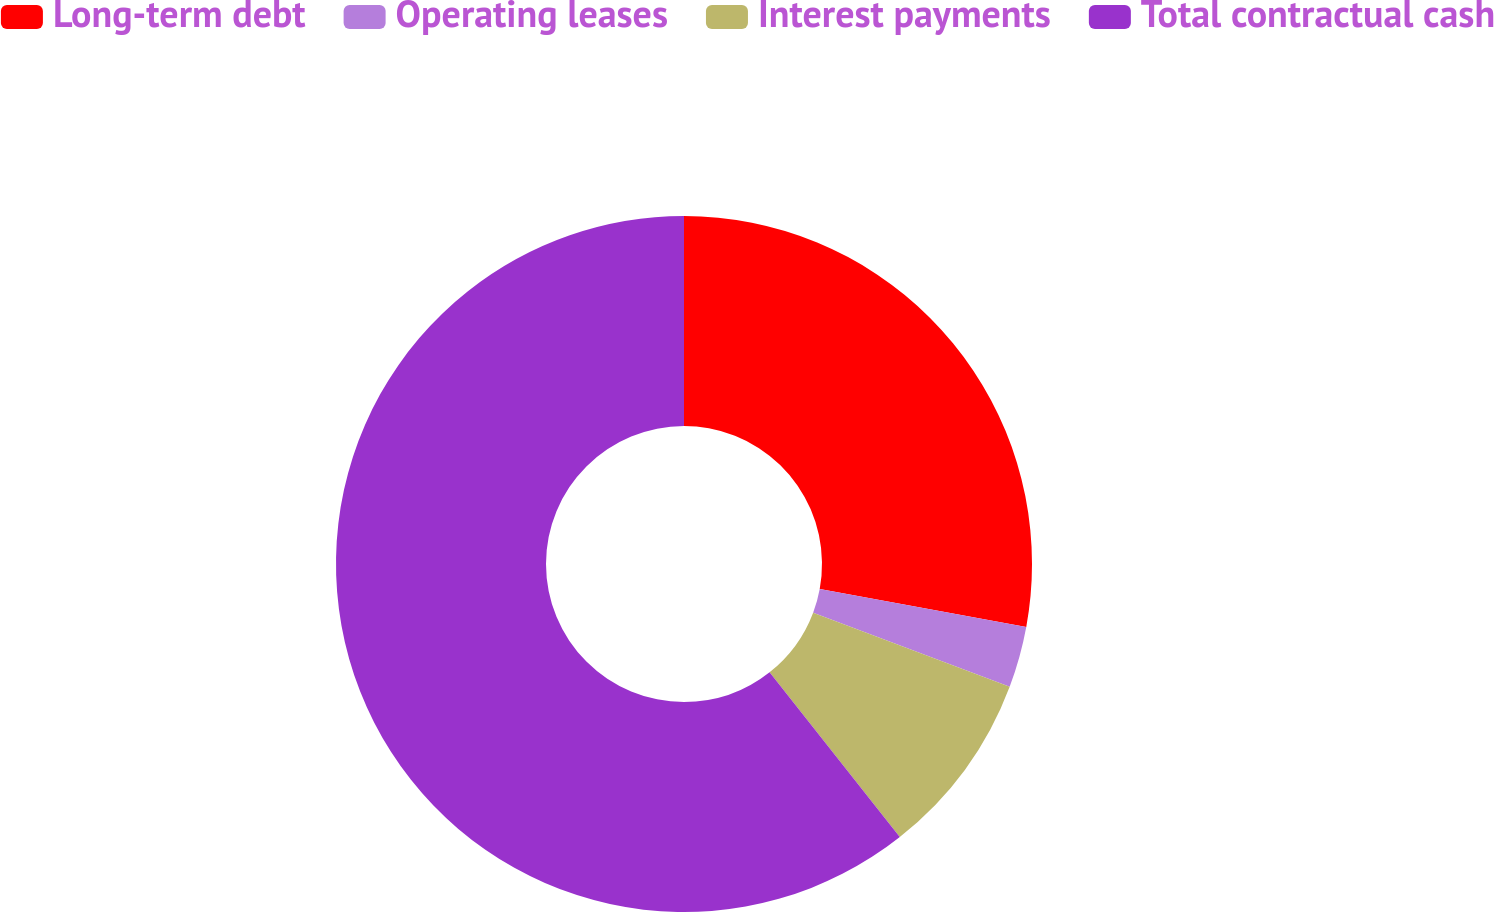<chart> <loc_0><loc_0><loc_500><loc_500><pie_chart><fcel>Long-term debt<fcel>Operating leases<fcel>Interest payments<fcel>Total contractual cash<nl><fcel>27.89%<fcel>2.84%<fcel>8.62%<fcel>60.64%<nl></chart> 